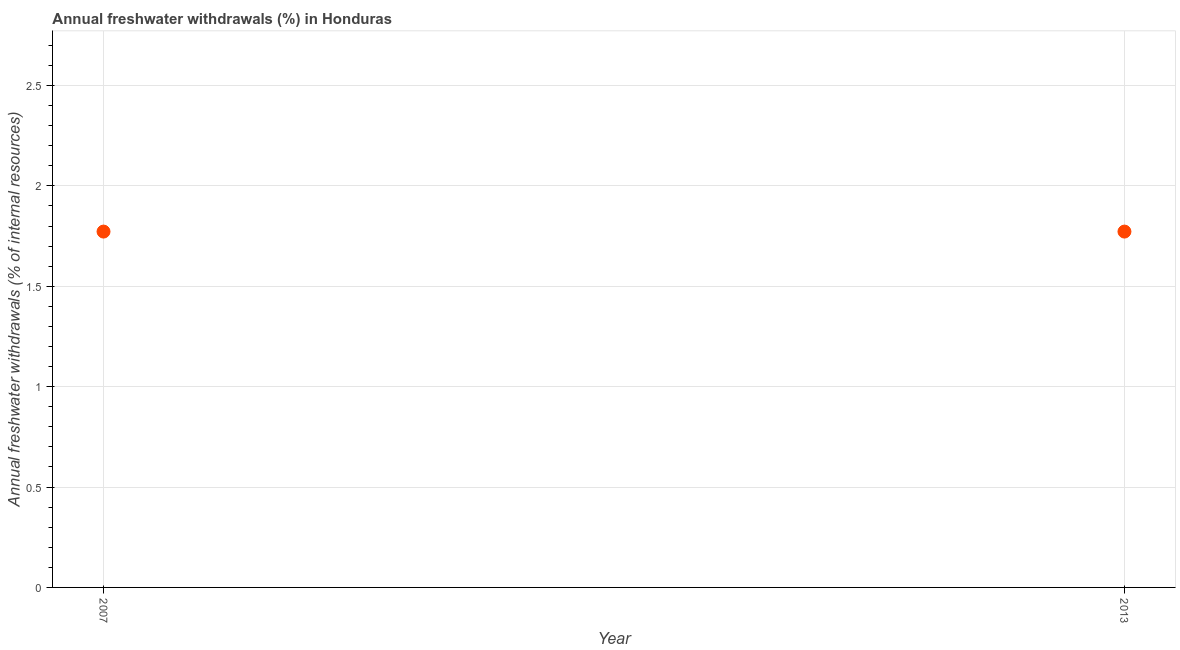What is the annual freshwater withdrawals in 2013?
Your response must be concise. 1.77. Across all years, what is the maximum annual freshwater withdrawals?
Keep it short and to the point. 1.77. Across all years, what is the minimum annual freshwater withdrawals?
Keep it short and to the point. 1.77. In which year was the annual freshwater withdrawals maximum?
Ensure brevity in your answer.  2007. What is the sum of the annual freshwater withdrawals?
Your response must be concise. 3.55. What is the difference between the annual freshwater withdrawals in 2007 and 2013?
Ensure brevity in your answer.  0. What is the average annual freshwater withdrawals per year?
Your response must be concise. 1.77. What is the median annual freshwater withdrawals?
Offer a very short reply. 1.77. Do a majority of the years between 2013 and 2007 (inclusive) have annual freshwater withdrawals greater than 0.1 %?
Keep it short and to the point. No. Is the annual freshwater withdrawals in 2007 less than that in 2013?
Offer a terse response. No. In how many years, is the annual freshwater withdrawals greater than the average annual freshwater withdrawals taken over all years?
Ensure brevity in your answer.  0. How many years are there in the graph?
Your answer should be very brief. 2. Does the graph contain any zero values?
Provide a short and direct response. No. Does the graph contain grids?
Provide a short and direct response. Yes. What is the title of the graph?
Offer a very short reply. Annual freshwater withdrawals (%) in Honduras. What is the label or title of the Y-axis?
Offer a very short reply. Annual freshwater withdrawals (% of internal resources). What is the Annual freshwater withdrawals (% of internal resources) in 2007?
Keep it short and to the point. 1.77. What is the Annual freshwater withdrawals (% of internal resources) in 2013?
Your answer should be very brief. 1.77. What is the difference between the Annual freshwater withdrawals (% of internal resources) in 2007 and 2013?
Your answer should be very brief. 0. 